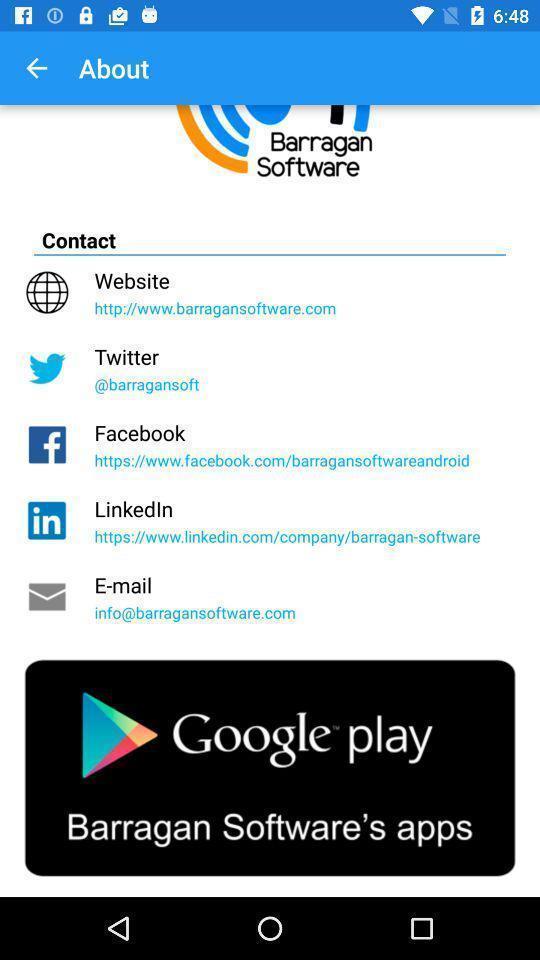Describe the content in this image. Page displaying various applications to contact. 